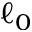Convert formula to latex. <formula><loc_0><loc_0><loc_500><loc_500>\ell _ { 0 }</formula> 